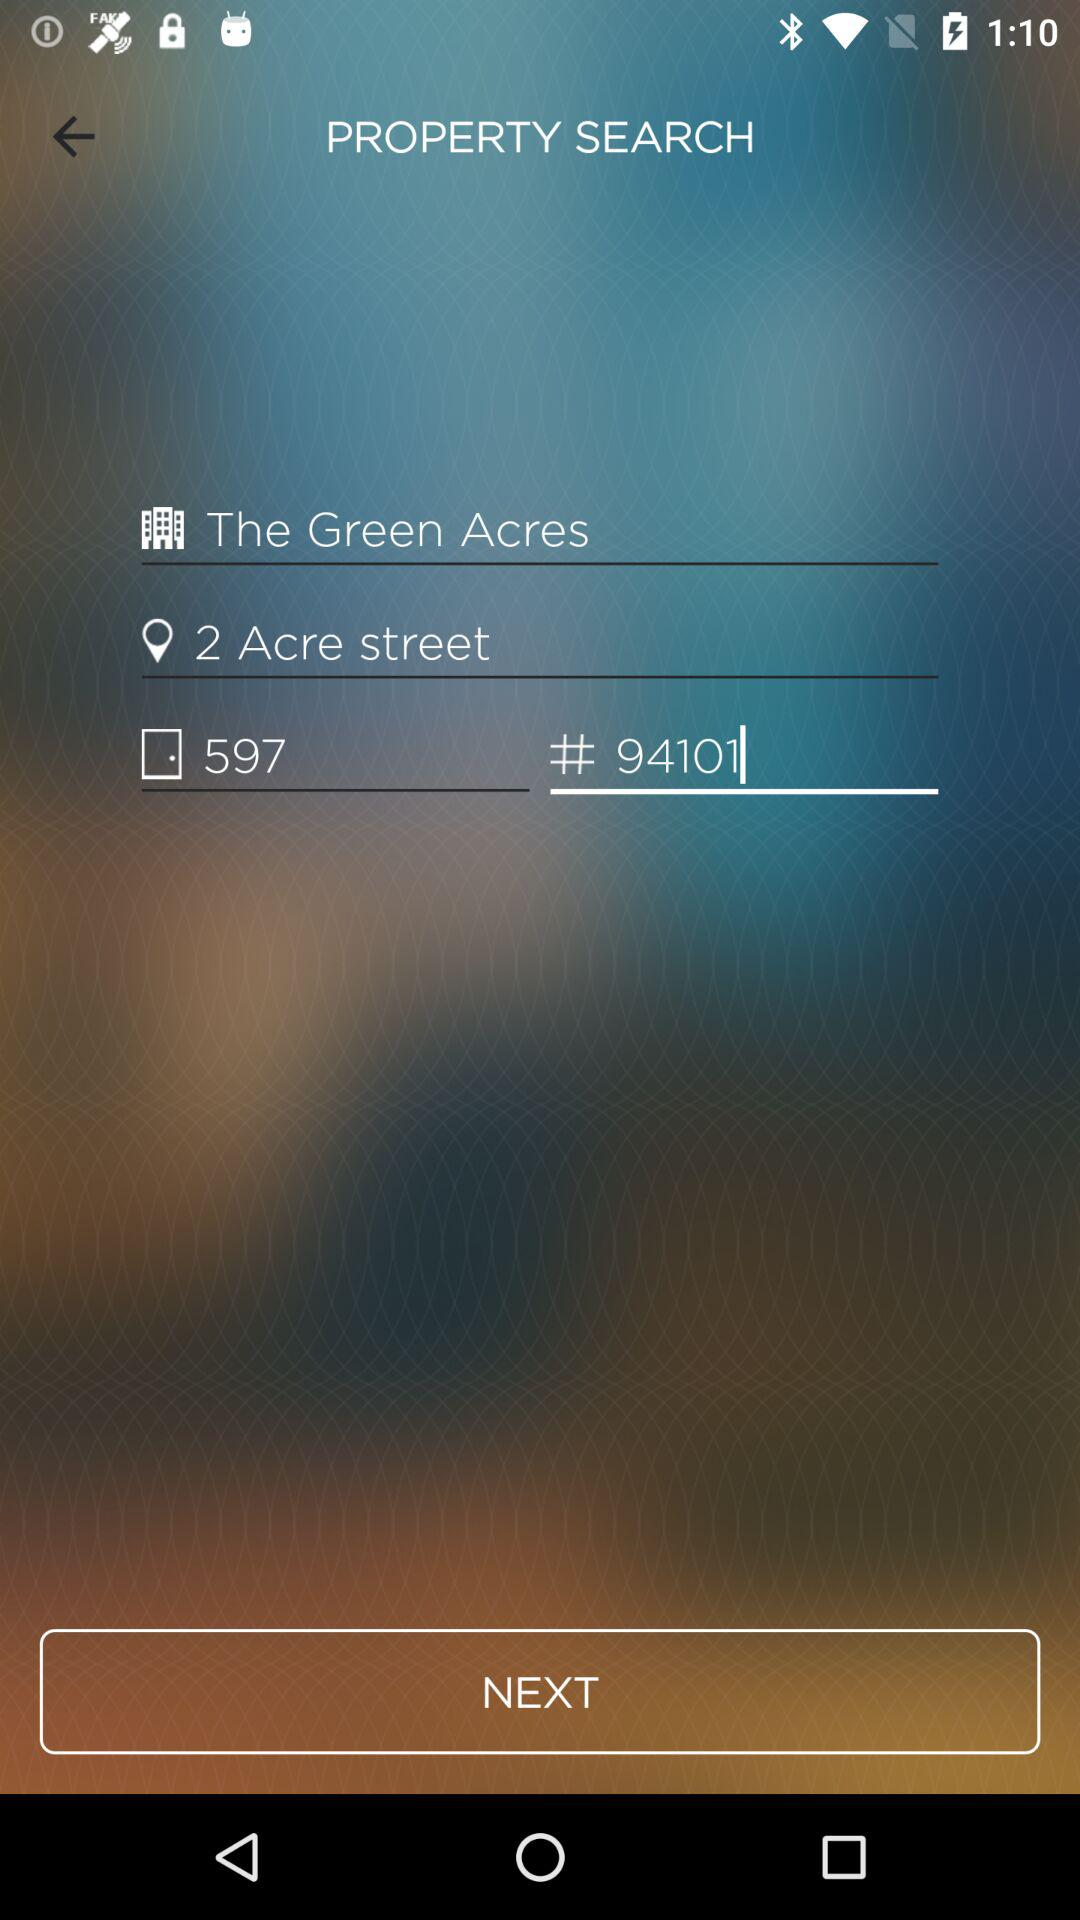What is the building number shown on the screen? The building number shown on the screen is 597. 